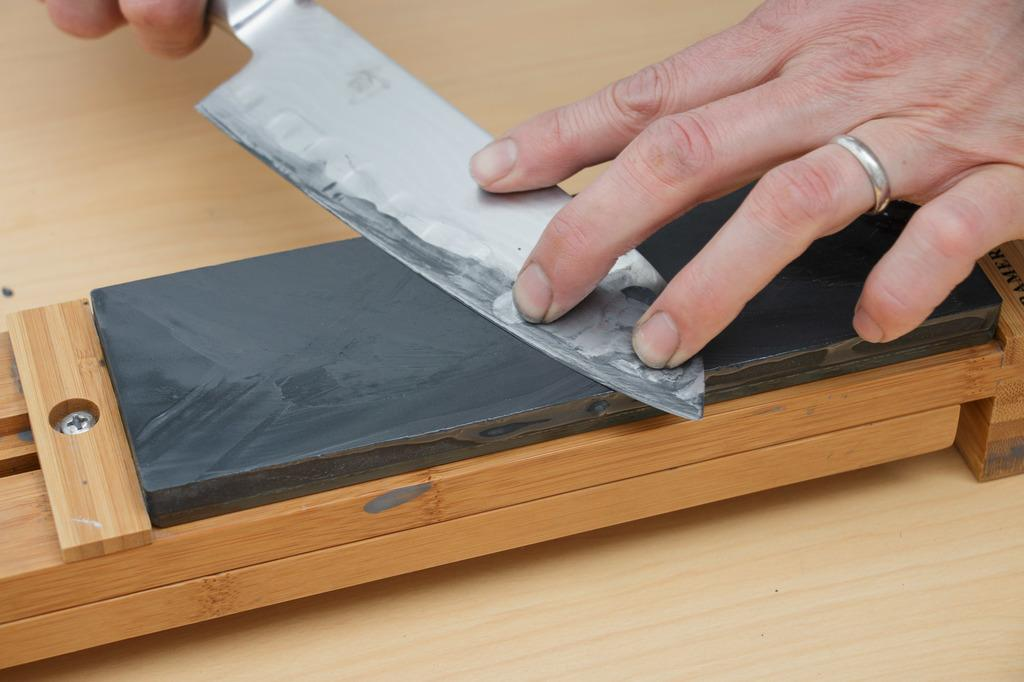What is the hand holding in the image? The hand is holding a knife in the image. What is the knife doing on the knife sharpener? The knife is on a knife sharpener in the image. Can you describe the other hand in the image? There is another hand in the top right of the image. What type of rock is being used as a cutting board in the image? There is no rock present in the image, and a cutting board is not mentioned in the provided facts. 